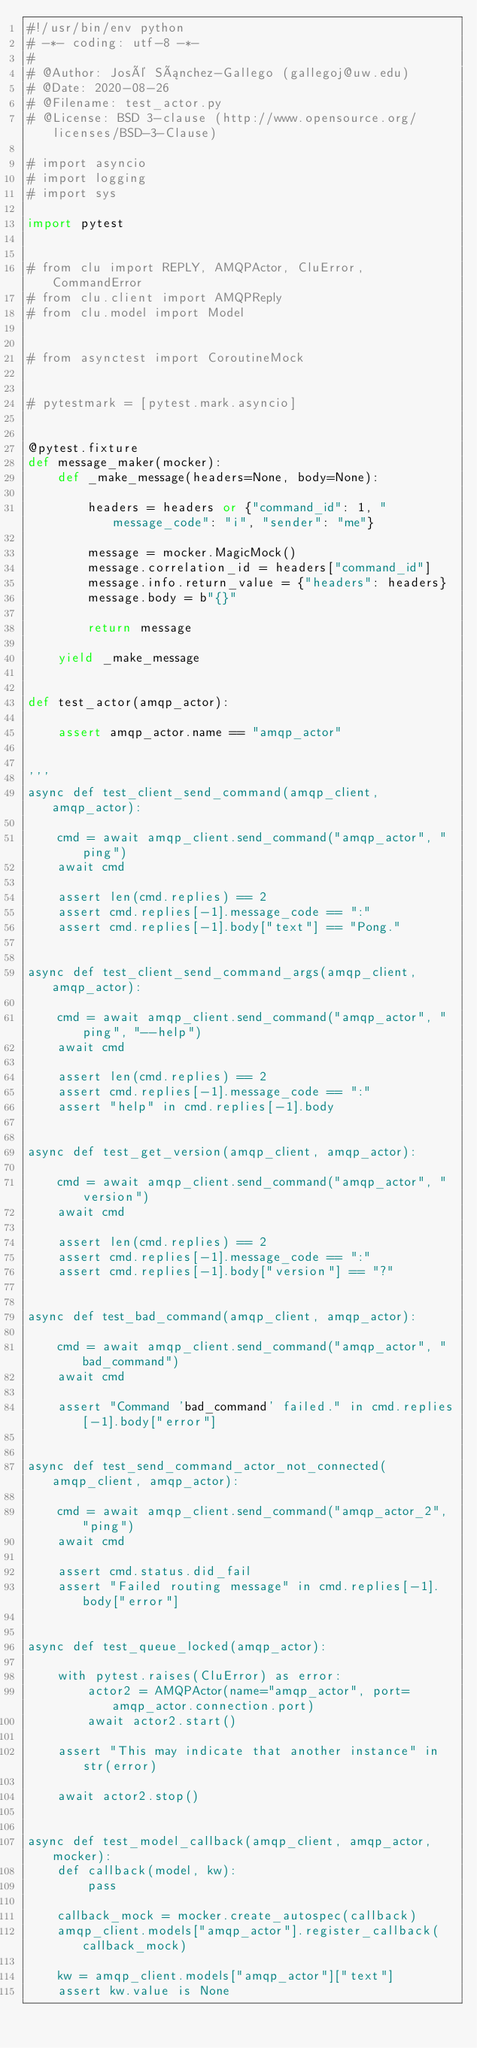Convert code to text. <code><loc_0><loc_0><loc_500><loc_500><_Python_>#!/usr/bin/env python
# -*- coding: utf-8 -*-
#
# @Author: José Sánchez-Gallego (gallegoj@uw.edu)
# @Date: 2020-08-26
# @Filename: test_actor.py
# @License: BSD 3-clause (http://www.opensource.org/licenses/BSD-3-Clause)

# import asyncio
# import logging
# import sys

import pytest


# from clu import REPLY, AMQPActor, CluError, CommandError
# from clu.client import AMQPReply
# from clu.model import Model


# from asynctest import CoroutineMock


# pytestmark = [pytest.mark.asyncio]


@pytest.fixture
def message_maker(mocker):
    def _make_message(headers=None, body=None):

        headers = headers or {"command_id": 1, "message_code": "i", "sender": "me"}

        message = mocker.MagicMock()
        message.correlation_id = headers["command_id"]
        message.info.return_value = {"headers": headers}
        message.body = b"{}"

        return message

    yield _make_message


def test_actor(amqp_actor):

    assert amqp_actor.name == "amqp_actor"


'''
async def test_client_send_command(amqp_client, amqp_actor):

    cmd = await amqp_client.send_command("amqp_actor", "ping")
    await cmd

    assert len(cmd.replies) == 2
    assert cmd.replies[-1].message_code == ":"
    assert cmd.replies[-1].body["text"] == "Pong."


async def test_client_send_command_args(amqp_client, amqp_actor):

    cmd = await amqp_client.send_command("amqp_actor", "ping", "--help")
    await cmd

    assert len(cmd.replies) == 2
    assert cmd.replies[-1].message_code == ":"
    assert "help" in cmd.replies[-1].body


async def test_get_version(amqp_client, amqp_actor):

    cmd = await amqp_client.send_command("amqp_actor", "version")
    await cmd

    assert len(cmd.replies) == 2
    assert cmd.replies[-1].message_code == ":"
    assert cmd.replies[-1].body["version"] == "?"


async def test_bad_command(amqp_client, amqp_actor):

    cmd = await amqp_client.send_command("amqp_actor", "bad_command")
    await cmd

    assert "Command 'bad_command' failed." in cmd.replies[-1].body["error"]


async def test_send_command_actor_not_connected(amqp_client, amqp_actor):

    cmd = await amqp_client.send_command("amqp_actor_2", "ping")
    await cmd

    assert cmd.status.did_fail
    assert "Failed routing message" in cmd.replies[-1].body["error"]


async def test_queue_locked(amqp_actor):

    with pytest.raises(CluError) as error:
        actor2 = AMQPActor(name="amqp_actor", port=amqp_actor.connection.port)
        await actor2.start()

    assert "This may indicate that another instance" in str(error)

    await actor2.stop()


async def test_model_callback(amqp_client, amqp_actor, mocker):
    def callback(model, kw):
        pass

    callback_mock = mocker.create_autospec(callback)
    amqp_client.models["amqp_actor"].register_callback(callback_mock)

    kw = amqp_client.models["amqp_actor"]["text"]
    assert kw.value is None
</code> 